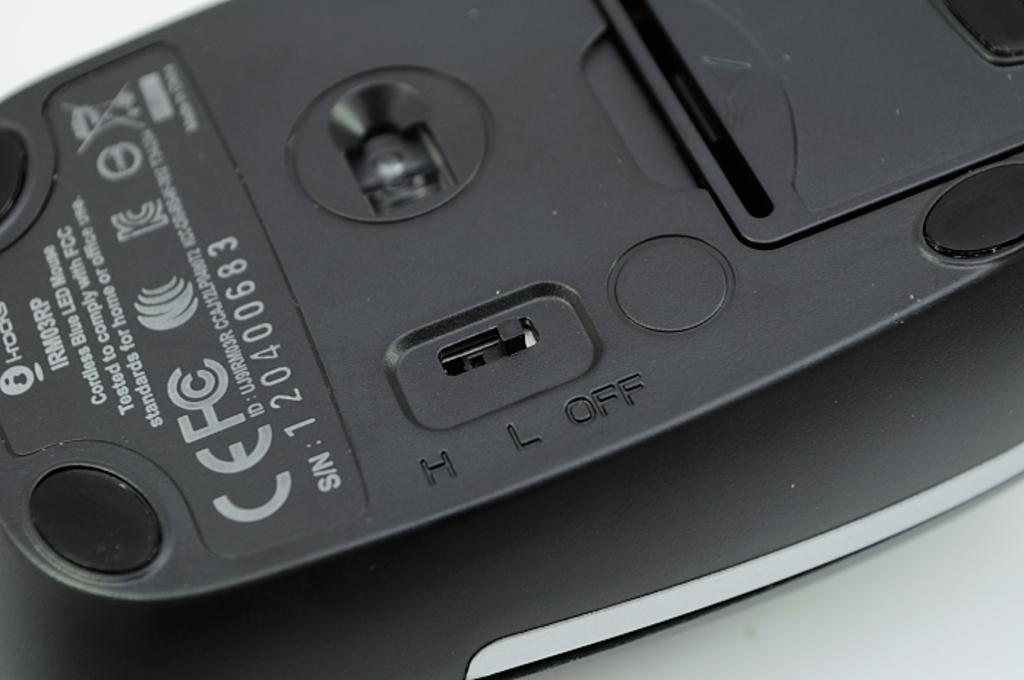<image>
Render a clear and concise summary of the photo. The back off the mouse where the off switch is displayed 